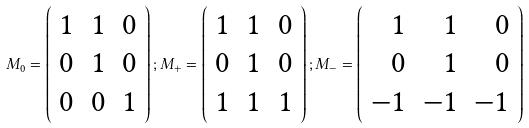<formula> <loc_0><loc_0><loc_500><loc_500>M _ { 0 } = \left ( \begin{array} { l l l } 1 & 1 & 0 \\ 0 & 1 & 0 \\ 0 & 0 & 1 \end{array} \right ) ; M _ { + } = \left ( \begin{array} { l l l } 1 & 1 & 0 \\ 0 & 1 & 0 \\ 1 & 1 & 1 \end{array} \right ) ; M _ { - } = \left ( \begin{array} { r r r } 1 & 1 & 0 \\ 0 & 1 & 0 \\ - 1 & - 1 & - 1 \end{array} \right )</formula> 